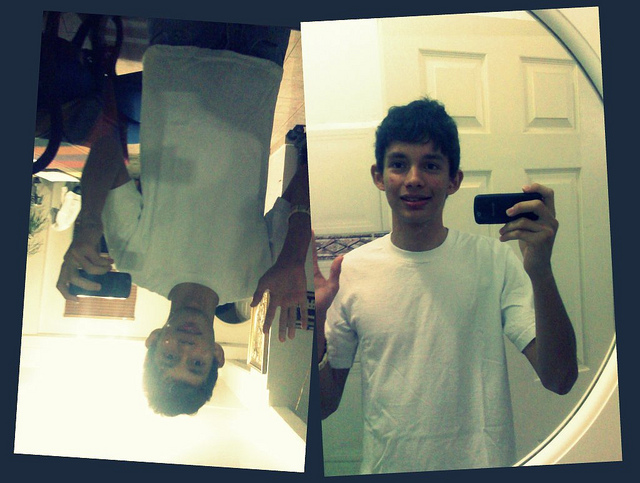Can you write a short story about what's happening in the image? In a quiet suburban home, sharegpt4v/sam had just returned from school. Eager to capture the moment, sharegpt4v/sam decided to take a few selfies. Holding the phone in one hand, sharegpt4v/sam snapped a few pictures in front of the mirror, enjoying the simple pleasure of capturing the day's excitement. In a playful mood, sharegpt4v/sam noticed the interesting reflection in the mirror, and with a burst of creativity, captured an upside-down reflection, giving a fun twist to the usual selfie routine. sharegpt4v/sam's smile in the photo was testament to the joy found in life's small, creative moments. 